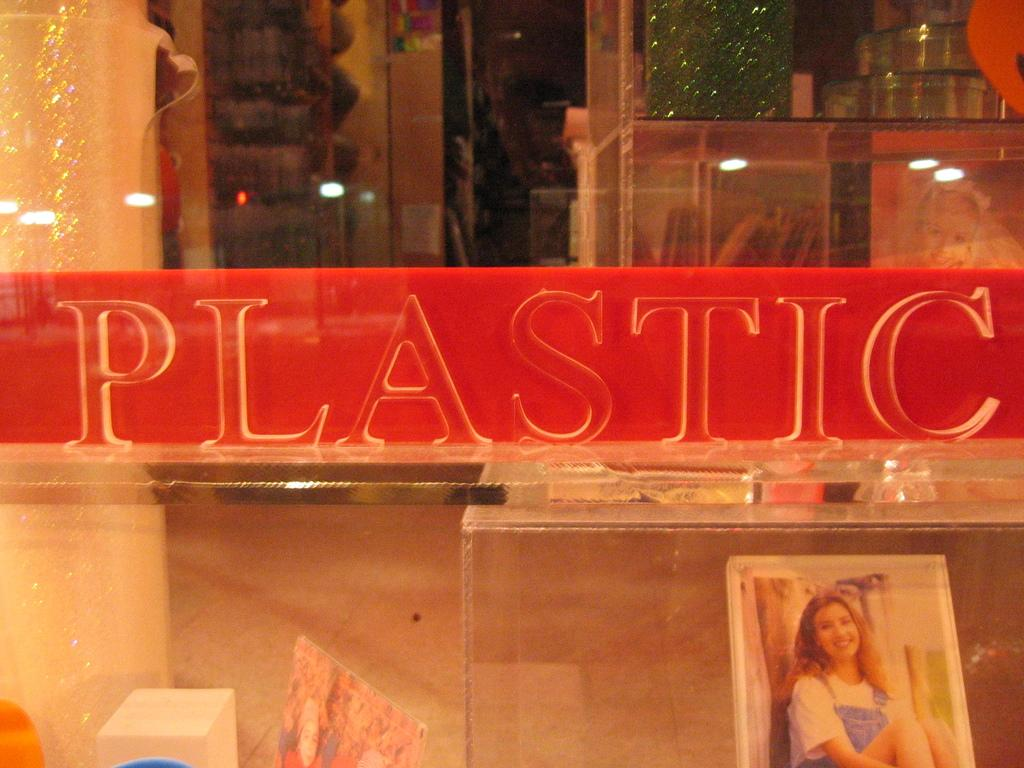What is the main object in the image with a red surface? There is a plastic object with a red surface in the image. Can you describe any other objects visible in the image? There are other objects visible in the background of the image, but their specific details are not mentioned in the provided facts. How many babies are sleeping in the crib in the image? There is no crib or babies present in the image. What type of cars can be seen driving in the background of the image? There is no mention of cars or a background in the provided facts, so we cannot answer this question. 